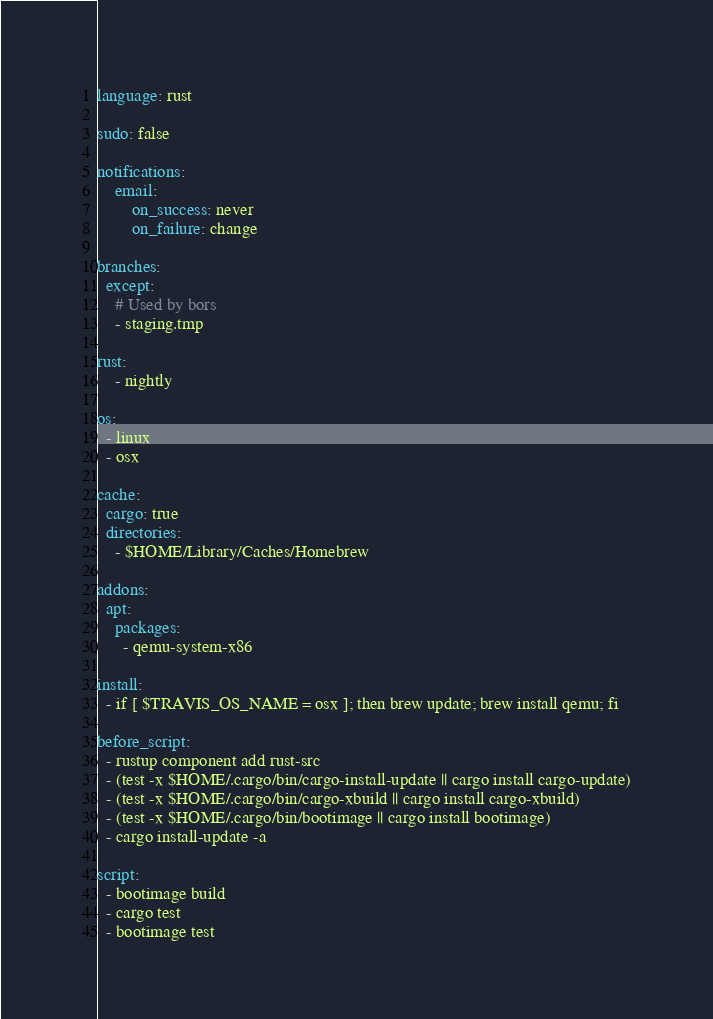Convert code to text. <code><loc_0><loc_0><loc_500><loc_500><_YAML_>language: rust

sudo: false

notifications:
    email:
        on_success: never
        on_failure: change

branches:
  except:
    # Used by bors
    - staging.tmp

rust:
    - nightly

os:
  - linux
  - osx

cache:
  cargo: true
  directories:
    - $HOME/Library/Caches/Homebrew

addons:
  apt:
    packages:
      - qemu-system-x86

install:
  - if [ $TRAVIS_OS_NAME = osx ]; then brew update; brew install qemu; fi

before_script:
  - rustup component add rust-src
  - (test -x $HOME/.cargo/bin/cargo-install-update || cargo install cargo-update)
  - (test -x $HOME/.cargo/bin/cargo-xbuild || cargo install cargo-xbuild)
  - (test -x $HOME/.cargo/bin/bootimage || cargo install bootimage)
  - cargo install-update -a

script:
  - bootimage build
  - cargo test
  - bootimage test
</code> 